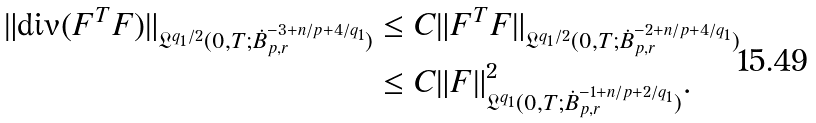<formula> <loc_0><loc_0><loc_500><loc_500>\| \text {div} ( F ^ { T } F ) \| _ { \mathfrak { L } ^ { q _ { 1 } / 2 } ( 0 , T ; \dot { B } ^ { - 3 + n / p + 4 / q _ { 1 } } _ { p , r } ) } & \leq C \| F ^ { T } F \| _ { \mathfrak { L } ^ { q _ { 1 } / 2 } ( 0 , T ; \dot { B } ^ { - 2 + n / p + 4 / q _ { 1 } } _ { p , r } ) } \\ & \leq C \| F \| _ { \mathfrak { L } ^ { q _ { 1 } } ( 0 , T ; \dot { B } ^ { - 1 + n / p + 2 / q _ { 1 } } _ { p , r } ) } ^ { 2 } .</formula> 